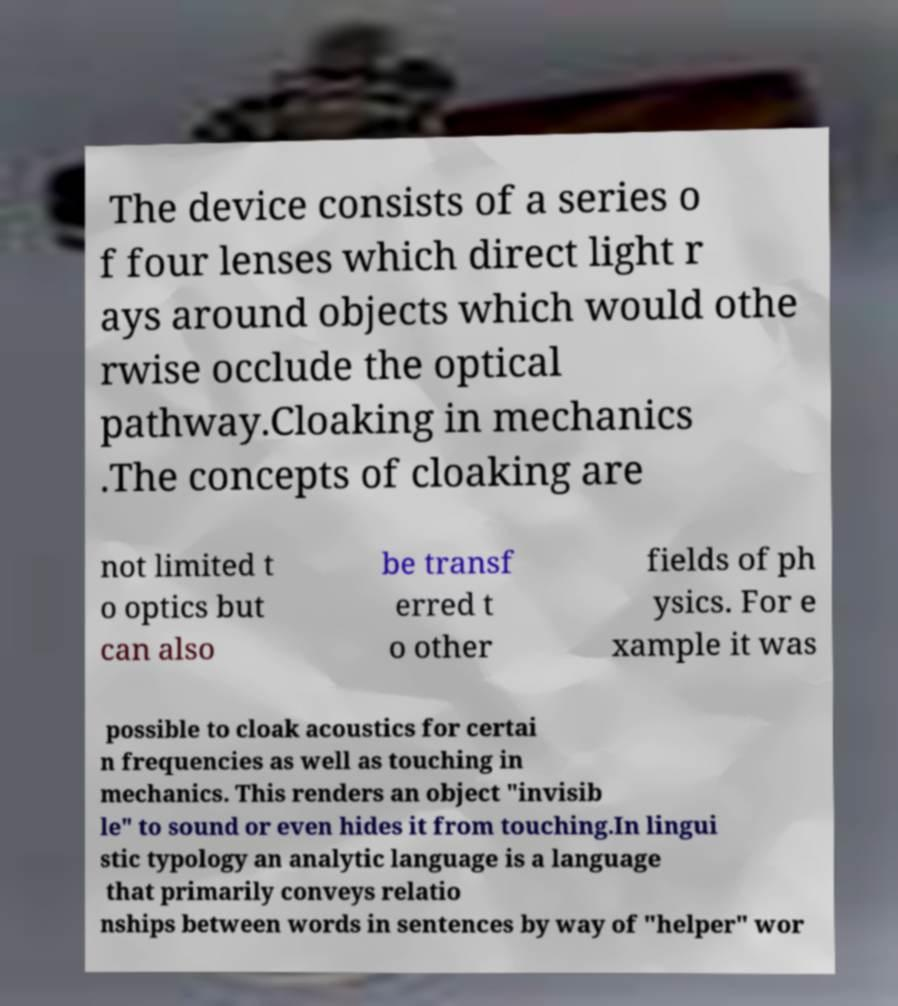Could you extract and type out the text from this image? The device consists of a series o f four lenses which direct light r ays around objects which would othe rwise occlude the optical pathway.Cloaking in mechanics .The concepts of cloaking are not limited t o optics but can also be transf erred t o other fields of ph ysics. For e xample it was possible to cloak acoustics for certai n frequencies as well as touching in mechanics. This renders an object "invisib le" to sound or even hides it from touching.In lingui stic typology an analytic language is a language that primarily conveys relatio nships between words in sentences by way of "helper" wor 